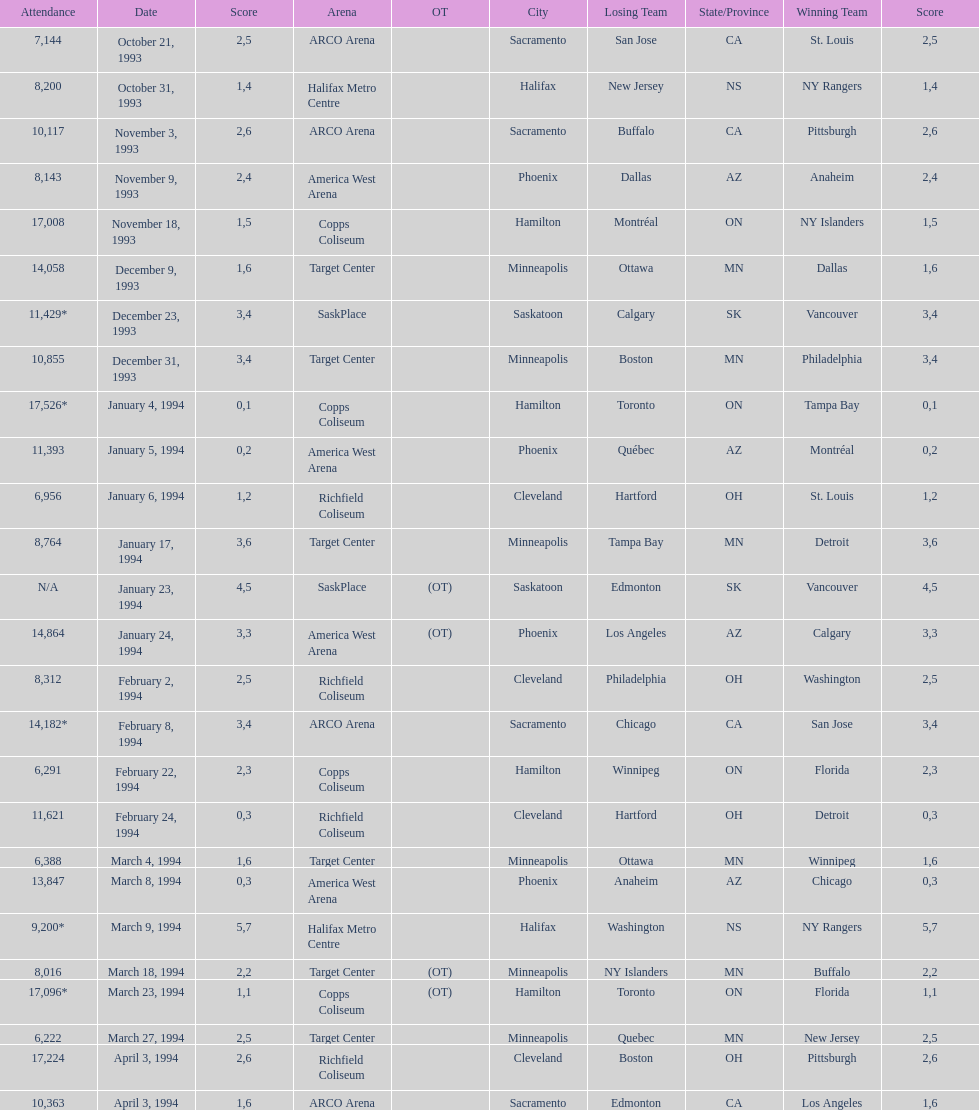Could you help me parse every detail presented in this table? {'header': ['Attendance', 'Date', 'Score', 'Arena', 'OT', 'City', 'Losing Team', 'State/Province', 'Winning Team', 'Score'], 'rows': [['7,144', 'October 21, 1993', '2', 'ARCO Arena', '', 'Sacramento', 'San Jose', 'CA', 'St. Louis', '5'], ['8,200', 'October 31, 1993', '1', 'Halifax Metro Centre', '', 'Halifax', 'New Jersey', 'NS', 'NY Rangers', '4'], ['10,117', 'November 3, 1993', '2', 'ARCO Arena', '', 'Sacramento', 'Buffalo', 'CA', 'Pittsburgh', '6'], ['8,143', 'November 9, 1993', '2', 'America West Arena', '', 'Phoenix', 'Dallas', 'AZ', 'Anaheim', '4'], ['17,008', 'November 18, 1993', '1', 'Copps Coliseum', '', 'Hamilton', 'Montréal', 'ON', 'NY Islanders', '5'], ['14,058', 'December 9, 1993', '1', 'Target Center', '', 'Minneapolis', 'Ottawa', 'MN', 'Dallas', '6'], ['11,429*', 'December 23, 1993', '3', 'SaskPlace', '', 'Saskatoon', 'Calgary', 'SK', 'Vancouver', '4'], ['10,855', 'December 31, 1993', '3', 'Target Center', '', 'Minneapolis', 'Boston', 'MN', 'Philadelphia', '4'], ['17,526*', 'January 4, 1994', '0', 'Copps Coliseum', '', 'Hamilton', 'Toronto', 'ON', 'Tampa Bay', '1'], ['11,393', 'January 5, 1994', '0', 'America West Arena', '', 'Phoenix', 'Québec', 'AZ', 'Montréal', '2'], ['6,956', 'January 6, 1994', '1', 'Richfield Coliseum', '', 'Cleveland', 'Hartford', 'OH', 'St. Louis', '2'], ['8,764', 'January 17, 1994', '3', 'Target Center', '', 'Minneapolis', 'Tampa Bay', 'MN', 'Detroit', '6'], ['N/A', 'January 23, 1994', '4', 'SaskPlace', '(OT)', 'Saskatoon', 'Edmonton', 'SK', 'Vancouver', '5'], ['14,864', 'January 24, 1994', '3', 'America West Arena', '(OT)', 'Phoenix', 'Los Angeles', 'AZ', 'Calgary', '3'], ['8,312', 'February 2, 1994', '2', 'Richfield Coliseum', '', 'Cleveland', 'Philadelphia', 'OH', 'Washington', '5'], ['14,182*', 'February 8, 1994', '3', 'ARCO Arena', '', 'Sacramento', 'Chicago', 'CA', 'San Jose', '4'], ['6,291', 'February 22, 1994', '2', 'Copps Coliseum', '', 'Hamilton', 'Winnipeg', 'ON', 'Florida', '3'], ['11,621', 'February 24, 1994', '0', 'Richfield Coliseum', '', 'Cleveland', 'Hartford', 'OH', 'Detroit', '3'], ['6,388', 'March 4, 1994', '1', 'Target Center', '', 'Minneapolis', 'Ottawa', 'MN', 'Winnipeg', '6'], ['13,847', 'March 8, 1994', '0', 'America West Arena', '', 'Phoenix', 'Anaheim', 'AZ', 'Chicago', '3'], ['9,200*', 'March 9, 1994', '5', 'Halifax Metro Centre', '', 'Halifax', 'Washington', 'NS', 'NY Rangers', '7'], ['8,016', 'March 18, 1994', '2', 'Target Center', '(OT)', 'Minneapolis', 'NY Islanders', 'MN', 'Buffalo', '2'], ['17,096*', 'March 23, 1994', '1', 'Copps Coliseum', '(OT)', 'Hamilton', 'Toronto', 'ON', 'Florida', '1'], ['6,222', 'March 27, 1994', '2', 'Target Center', '', 'Minneapolis', 'Quebec', 'MN', 'New Jersey', '5'], ['17,224', 'April 3, 1994', '2', 'Richfield Coliseum', '', 'Cleveland', 'Boston', 'OH', 'Pittsburgh', '6'], ['10,363', 'April 3, 1994', '1', 'ARCO Arena', '', 'Sacramento', 'Edmonton', 'CA', 'Los Angeles', '6']]} How many events occurred in minneapolis, mn? 6. 